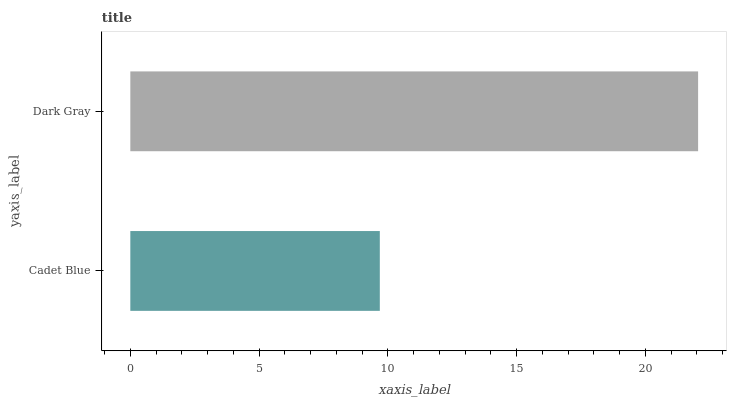Is Cadet Blue the minimum?
Answer yes or no. Yes. Is Dark Gray the maximum?
Answer yes or no. Yes. Is Dark Gray the minimum?
Answer yes or no. No. Is Dark Gray greater than Cadet Blue?
Answer yes or no. Yes. Is Cadet Blue less than Dark Gray?
Answer yes or no. Yes. Is Cadet Blue greater than Dark Gray?
Answer yes or no. No. Is Dark Gray less than Cadet Blue?
Answer yes or no. No. Is Dark Gray the high median?
Answer yes or no. Yes. Is Cadet Blue the low median?
Answer yes or no. Yes. Is Cadet Blue the high median?
Answer yes or no. No. Is Dark Gray the low median?
Answer yes or no. No. 